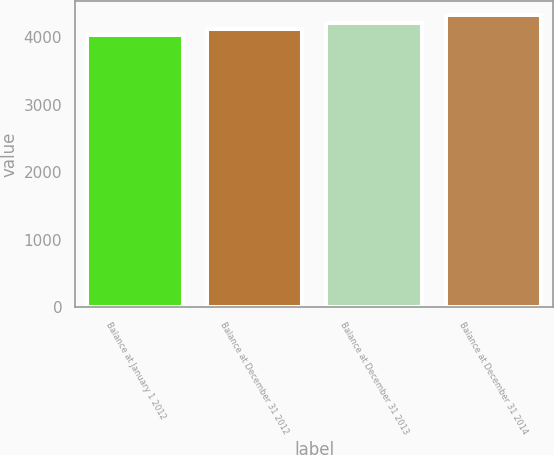Convert chart. <chart><loc_0><loc_0><loc_500><loc_500><bar_chart><fcel>Balance at January 1 2012<fcel>Balance at December 31 2012<fcel>Balance at December 31 2013<fcel>Balance at December 31 2014<nl><fcel>4031<fcel>4113<fcel>4210<fcel>4321<nl></chart> 